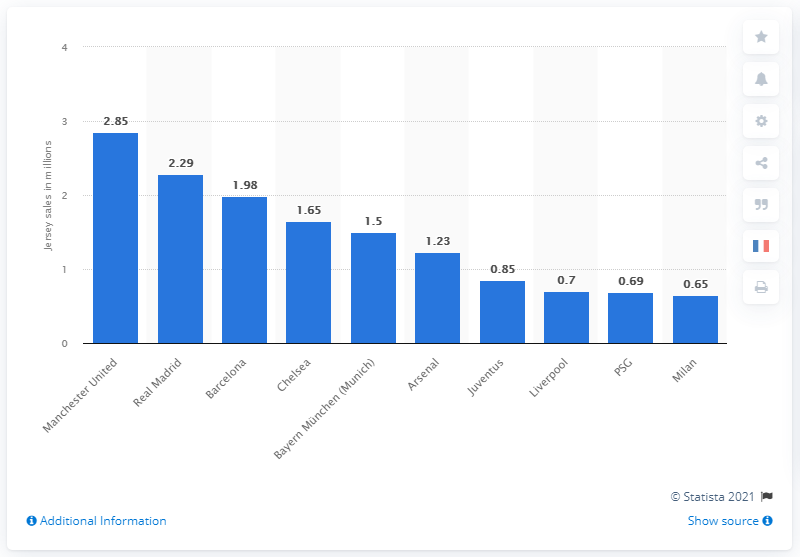Mention a couple of crucial points in this snapshot. Manchester United was the most popular football team in Europe in 2016. 